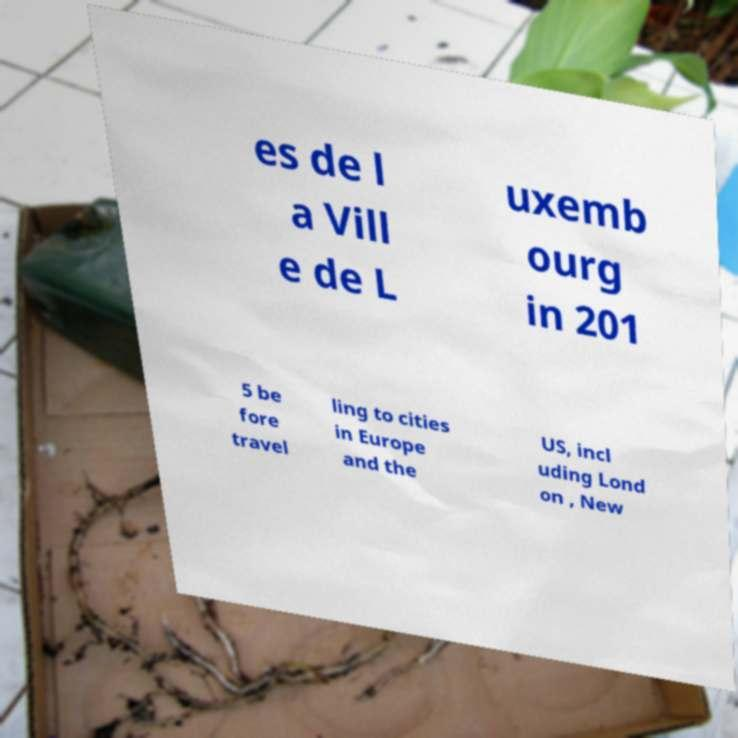Could you assist in decoding the text presented in this image and type it out clearly? es de l a Vill e de L uxemb ourg in 201 5 be fore travel ling to cities in Europe and the US, incl uding Lond on , New 